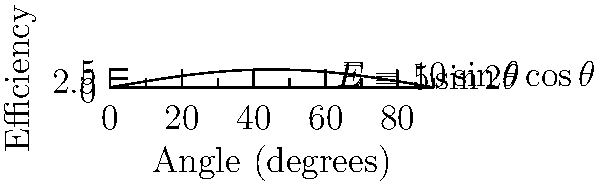A conveyor belt is used to transport material up an incline. The efficiency $E$ of material transport is given by the equation $E = 10\sin\theta\cos\theta$, where $\theta$ is the angle of inclination in degrees. Determine the optimal angle $\theta$ that maximizes the transport efficiency. To find the optimal angle, we need to maximize the function $E(\theta) = 10\sin\theta\cos\theta$. We can solve this problem using the following steps:

1) First, recognize that $\sin\theta\cos\theta = \frac{1}{2}\sin2\theta$. So, we can rewrite the equation as:
   $E(\theta) = 5\sin2\theta$

2) To find the maximum, we need to find where the derivative equals zero:
   $\frac{dE}{d\theta} = 10\cos2\theta$

3) Set this equal to zero and solve:
   $10\cos2\theta = 0$
   $\cos2\theta = 0$

4) The cosine function equals zero when its argument is $\frac{\pi}{2}$ (or 90°) plus any multiple of $\pi$ (or 180°). So:
   $2\theta = \frac{\pi}{2} + n\pi$, where $n$ is an integer

5) Solving for $\theta$:
   $\theta = \frac{\pi}{4} + \frac{n\pi}{2}$

6) Since we're dealing with a physical angle, we're only interested in the solution in the first quadrant (0° to 90°). This corresponds to $n = 0$:
   $\theta = \frac{\pi}{4} = 45°$

7) To confirm this is a maximum (not a minimum), we can check the second derivative:
   $\frac{d^2E}{d\theta^2} = -20\sin2\theta$
   At $\theta = 45°$, this is negative, confirming a maximum.

Therefore, the optimal angle for maximum transport efficiency is 45°.
Answer: 45° 